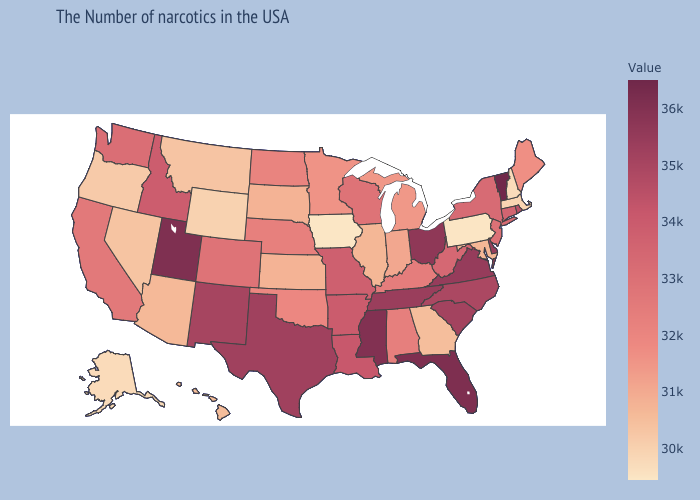Does Wyoming have the lowest value in the USA?
Write a very short answer. No. Among the states that border Alabama , which have the lowest value?
Give a very brief answer. Georgia. Which states have the lowest value in the USA?
Give a very brief answer. Iowa. Among the states that border Oklahoma , does Texas have the lowest value?
Quick response, please. No. Which states have the highest value in the USA?
Answer briefly. Vermont. Is the legend a continuous bar?
Keep it brief. Yes. Which states have the lowest value in the USA?
Give a very brief answer. Iowa. 